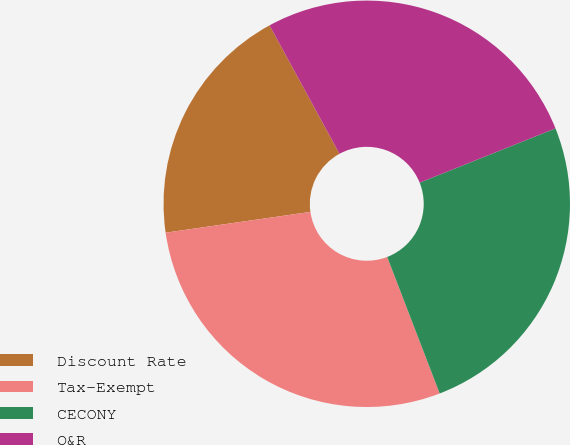<chart> <loc_0><loc_0><loc_500><loc_500><pie_chart><fcel>Discount Rate<fcel>Tax-Exempt<fcel>CECONY<fcel>O&R<nl><fcel>19.33%<fcel>28.57%<fcel>25.21%<fcel>26.89%<nl></chart> 